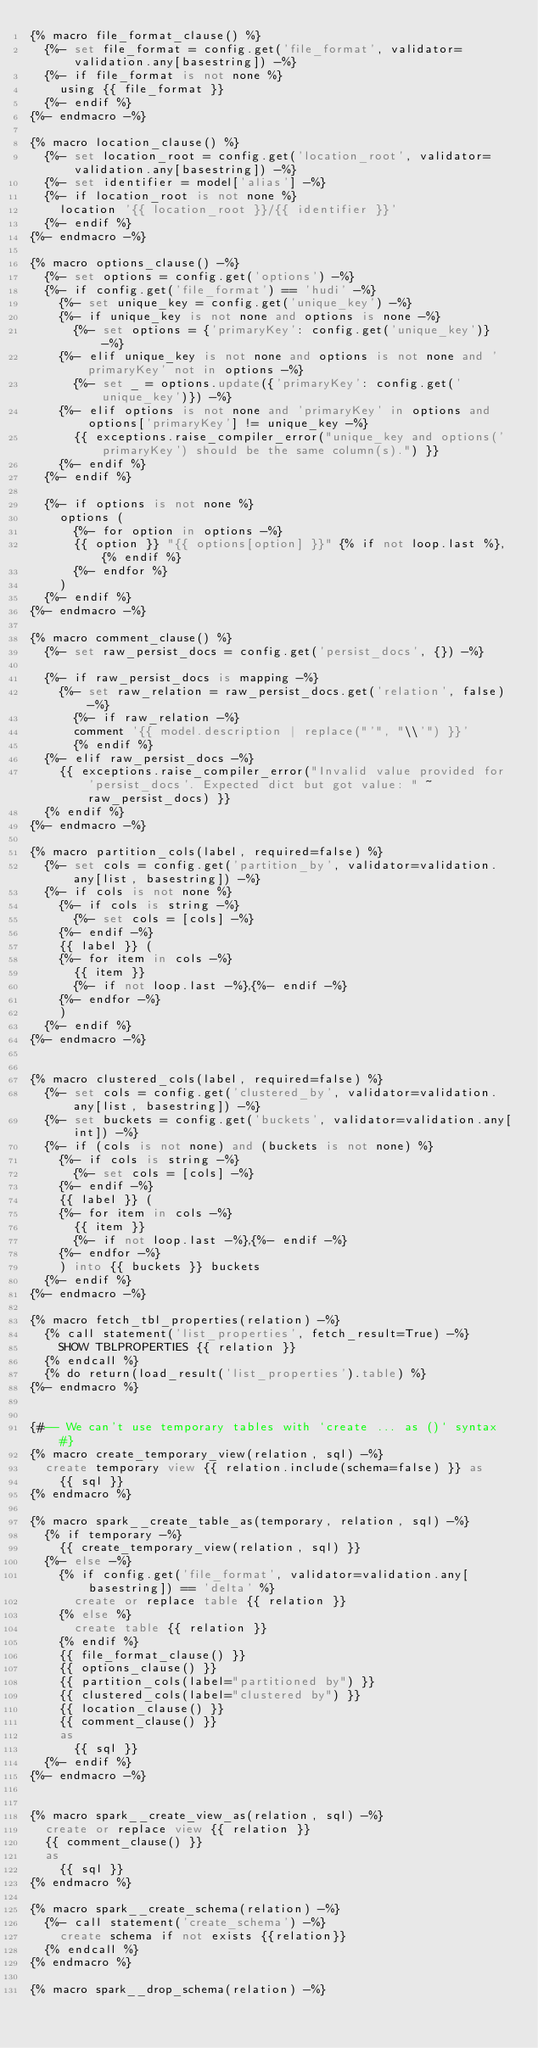Convert code to text. <code><loc_0><loc_0><loc_500><loc_500><_SQL_>{% macro file_format_clause() %}
  {%- set file_format = config.get('file_format', validator=validation.any[basestring]) -%}
  {%- if file_format is not none %}
    using {{ file_format }}
  {%- endif %}
{%- endmacro -%}

{% macro location_clause() %}
  {%- set location_root = config.get('location_root', validator=validation.any[basestring]) -%}
  {%- set identifier = model['alias'] -%}
  {%- if location_root is not none %}
    location '{{ location_root }}/{{ identifier }}'
  {%- endif %}
{%- endmacro -%}

{% macro options_clause() -%}
  {%- set options = config.get('options') -%}
  {%- if config.get('file_format') == 'hudi' -%}
    {%- set unique_key = config.get('unique_key') -%}
    {%- if unique_key is not none and options is none -%}
      {%- set options = {'primaryKey': config.get('unique_key')} -%}
    {%- elif unique_key is not none and options is not none and 'primaryKey' not in options -%}
      {%- set _ = options.update({'primaryKey': config.get('unique_key')}) -%}
    {%- elif options is not none and 'primaryKey' in options and options['primaryKey'] != unique_key -%}
      {{ exceptions.raise_compiler_error("unique_key and options('primaryKey') should be the same column(s).") }}
    {%- endif %}
  {%- endif %}

  {%- if options is not none %}
    options (
      {%- for option in options -%}
      {{ option }} "{{ options[option] }}" {% if not loop.last %}, {% endif %}
      {%- endfor %}
    )
  {%- endif %}
{%- endmacro -%}

{% macro comment_clause() %}
  {%- set raw_persist_docs = config.get('persist_docs', {}) -%}

  {%- if raw_persist_docs is mapping -%}
    {%- set raw_relation = raw_persist_docs.get('relation', false) -%}
      {%- if raw_relation -%}
      comment '{{ model.description | replace("'", "\\'") }}'
      {% endif %}
  {%- elif raw_persist_docs -%}
    {{ exceptions.raise_compiler_error("Invalid value provided for 'persist_docs'. Expected dict but got value: " ~ raw_persist_docs) }}
  {% endif %}
{%- endmacro -%}

{% macro partition_cols(label, required=false) %}
  {%- set cols = config.get('partition_by', validator=validation.any[list, basestring]) -%}
  {%- if cols is not none %}
    {%- if cols is string -%}
      {%- set cols = [cols] -%}
    {%- endif -%}
    {{ label }} (
    {%- for item in cols -%}
      {{ item }}
      {%- if not loop.last -%},{%- endif -%}
    {%- endfor -%}
    )
  {%- endif %}
{%- endmacro -%}


{% macro clustered_cols(label, required=false) %}
  {%- set cols = config.get('clustered_by', validator=validation.any[list, basestring]) -%}
  {%- set buckets = config.get('buckets', validator=validation.any[int]) -%}
  {%- if (cols is not none) and (buckets is not none) %}
    {%- if cols is string -%}
      {%- set cols = [cols] -%}
    {%- endif -%}
    {{ label }} (
    {%- for item in cols -%}
      {{ item }}
      {%- if not loop.last -%},{%- endif -%}
    {%- endfor -%}
    ) into {{ buckets }} buckets
  {%- endif %}
{%- endmacro -%}

{% macro fetch_tbl_properties(relation) -%}
  {% call statement('list_properties', fetch_result=True) -%}
    SHOW TBLPROPERTIES {{ relation }}
  {% endcall %}
  {% do return(load_result('list_properties').table) %}
{%- endmacro %}


{#-- We can't use temporary tables with `create ... as ()` syntax #}
{% macro create_temporary_view(relation, sql) -%}
  create temporary view {{ relation.include(schema=false) }} as
    {{ sql }}
{% endmacro %}

{% macro spark__create_table_as(temporary, relation, sql) -%}
  {% if temporary -%}
    {{ create_temporary_view(relation, sql) }}
  {%- else -%}
    {% if config.get('file_format', validator=validation.any[basestring]) == 'delta' %}
      create or replace table {{ relation }}
    {% else %}
      create table {{ relation }}
    {% endif %}
    {{ file_format_clause() }}
    {{ options_clause() }}
    {{ partition_cols(label="partitioned by") }}
    {{ clustered_cols(label="clustered by") }}
    {{ location_clause() }}
    {{ comment_clause() }}
    as
      {{ sql }}
  {%- endif %}
{%- endmacro -%}


{% macro spark__create_view_as(relation, sql) -%}
  create or replace view {{ relation }}
  {{ comment_clause() }}
  as
    {{ sql }}
{% endmacro %}

{% macro spark__create_schema(relation) -%}
  {%- call statement('create_schema') -%}
    create schema if not exists {{relation}}
  {% endcall %}
{% endmacro %}

{% macro spark__drop_schema(relation) -%}</code> 